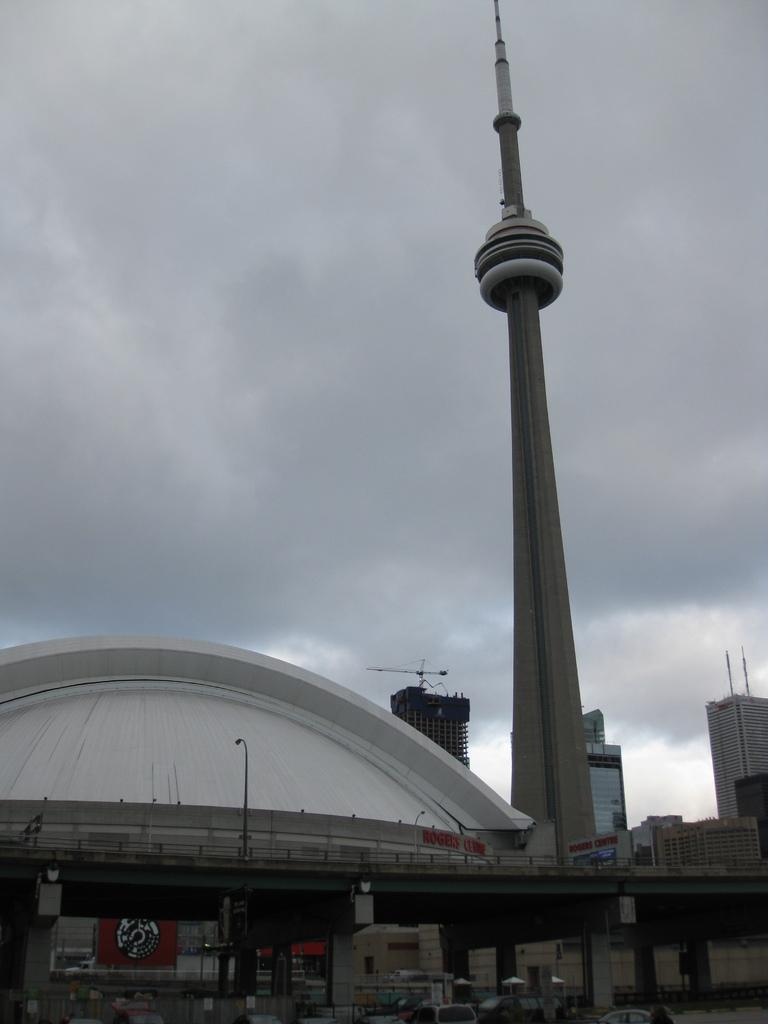What is the main structure in the image? There is a tower in the image. What type of establishments can be seen in the image? There are shops in the image. What can be seen in the background of the image? There are buildings in the background of the image. How would you describe the weather based on the image? The sky is cloudy in the background of the image, suggesting a cloudy day. What type of lettuce is being sold in the shops in the image? There is no lettuce or indication of any specific items being sold in the shops in the image. 